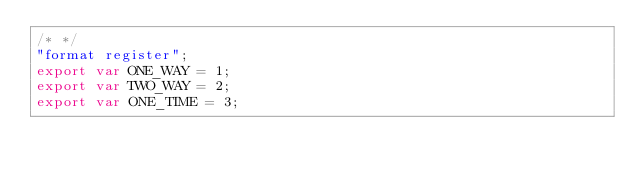<code> <loc_0><loc_0><loc_500><loc_500><_JavaScript_>/* */ 
"format register";
export var ONE_WAY = 1;
export var TWO_WAY = 2;
export var ONE_TIME = 3;
</code> 